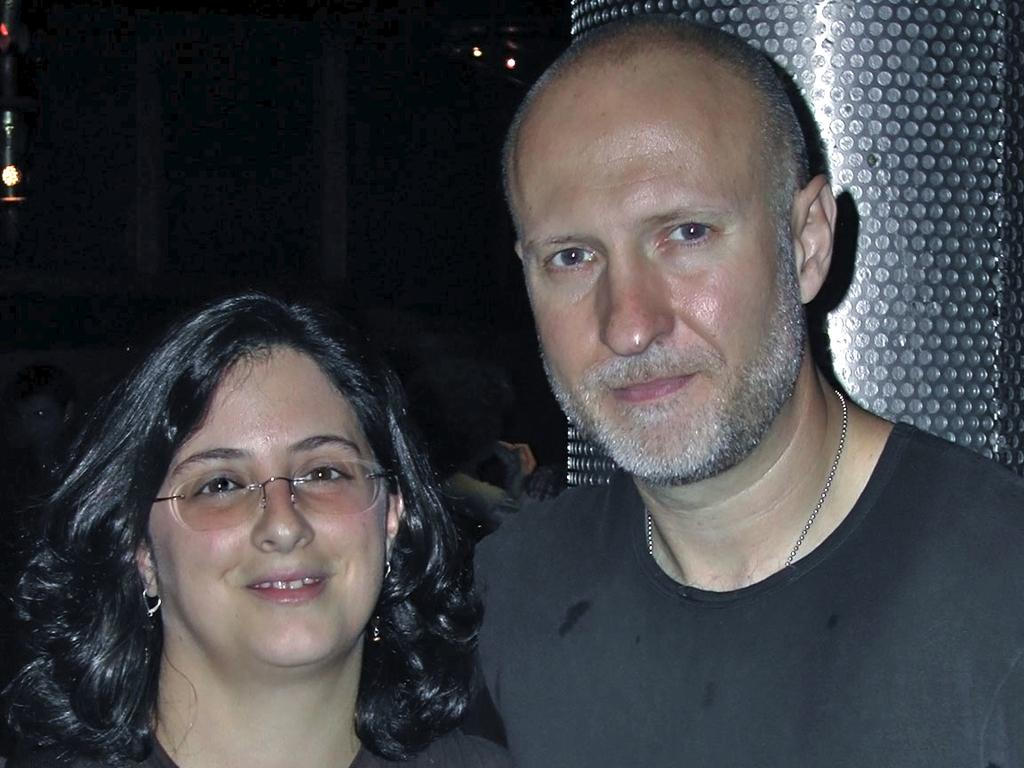How many people are in the image? There are two people in the image, a man and a woman. What are the expressions on their faces? Both the man and the woman are smiling in the image. What can be seen in the background of the image? The background of the image is dark, and there are lights visible. What architectural feature is present in the image? There is a pillar in the image. What type of vegetable is being harvested on the farm in the image? There is no farm or vegetable present in the image. What is the condition of the man's health in the image? There is no information about the man's health in the image. 